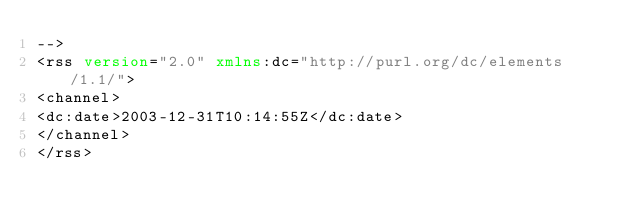Convert code to text. <code><loc_0><loc_0><loc_500><loc_500><_XML_>-->
<rss version="2.0" xmlns:dc="http://purl.org/dc/elements/1.1/">
<channel>
<dc:date>2003-12-31T10:14:55Z</dc:date>
</channel>
</rss>
</code> 